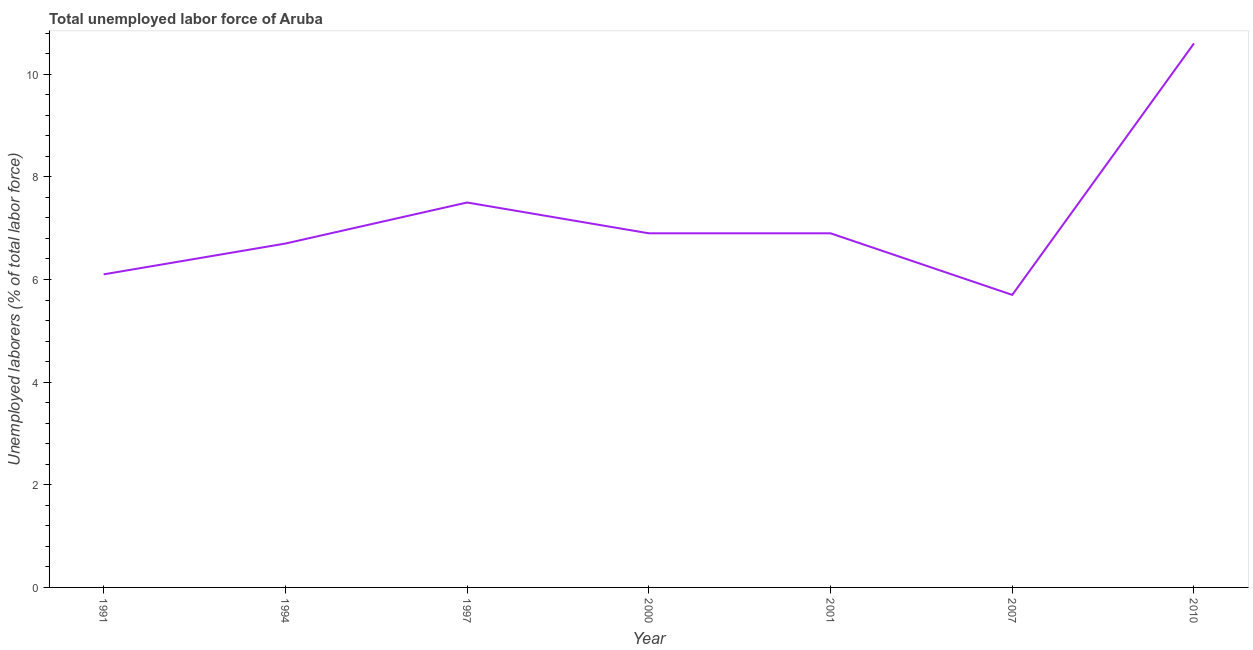What is the total unemployed labour force in 2001?
Provide a short and direct response. 6.9. Across all years, what is the maximum total unemployed labour force?
Provide a succinct answer. 10.6. Across all years, what is the minimum total unemployed labour force?
Make the answer very short. 5.7. What is the sum of the total unemployed labour force?
Make the answer very short. 50.4. What is the difference between the total unemployed labour force in 1994 and 2010?
Offer a very short reply. -3.9. What is the average total unemployed labour force per year?
Give a very brief answer. 7.2. What is the median total unemployed labour force?
Your answer should be very brief. 6.9. What is the ratio of the total unemployed labour force in 1997 to that in 2007?
Your answer should be very brief. 1.32. Is the total unemployed labour force in 2007 less than that in 2010?
Keep it short and to the point. Yes. Is the difference between the total unemployed labour force in 1991 and 2001 greater than the difference between any two years?
Offer a terse response. No. What is the difference between the highest and the second highest total unemployed labour force?
Your response must be concise. 3.1. What is the difference between the highest and the lowest total unemployed labour force?
Offer a very short reply. 4.9. How many lines are there?
Your answer should be compact. 1. What is the difference between two consecutive major ticks on the Y-axis?
Your answer should be compact. 2. Does the graph contain grids?
Keep it short and to the point. No. What is the title of the graph?
Offer a terse response. Total unemployed labor force of Aruba. What is the label or title of the Y-axis?
Offer a terse response. Unemployed laborers (% of total labor force). What is the Unemployed laborers (% of total labor force) in 1991?
Provide a short and direct response. 6.1. What is the Unemployed laborers (% of total labor force) of 1994?
Provide a succinct answer. 6.7. What is the Unemployed laborers (% of total labor force) of 1997?
Offer a terse response. 7.5. What is the Unemployed laborers (% of total labor force) of 2000?
Provide a short and direct response. 6.9. What is the Unemployed laborers (% of total labor force) of 2001?
Your answer should be compact. 6.9. What is the Unemployed laborers (% of total labor force) in 2007?
Your answer should be very brief. 5.7. What is the Unemployed laborers (% of total labor force) in 2010?
Your answer should be compact. 10.6. What is the difference between the Unemployed laborers (% of total labor force) in 1991 and 1994?
Make the answer very short. -0.6. What is the difference between the Unemployed laborers (% of total labor force) in 1991 and 1997?
Your answer should be compact. -1.4. What is the difference between the Unemployed laborers (% of total labor force) in 1991 and 2000?
Ensure brevity in your answer.  -0.8. What is the difference between the Unemployed laborers (% of total labor force) in 1991 and 2010?
Provide a succinct answer. -4.5. What is the difference between the Unemployed laborers (% of total labor force) in 1994 and 1997?
Your answer should be compact. -0.8. What is the difference between the Unemployed laborers (% of total labor force) in 1994 and 2001?
Ensure brevity in your answer.  -0.2. What is the difference between the Unemployed laborers (% of total labor force) in 1994 and 2007?
Make the answer very short. 1. What is the difference between the Unemployed laborers (% of total labor force) in 1994 and 2010?
Ensure brevity in your answer.  -3.9. What is the difference between the Unemployed laborers (% of total labor force) in 1997 and 2000?
Ensure brevity in your answer.  0.6. What is the difference between the Unemployed laborers (% of total labor force) in 1997 and 2007?
Make the answer very short. 1.8. What is the difference between the Unemployed laborers (% of total labor force) in 1997 and 2010?
Your answer should be very brief. -3.1. What is the difference between the Unemployed laborers (% of total labor force) in 2000 and 2001?
Give a very brief answer. 0. What is the difference between the Unemployed laborers (% of total labor force) in 2001 and 2007?
Give a very brief answer. 1.2. What is the difference between the Unemployed laborers (% of total labor force) in 2001 and 2010?
Offer a very short reply. -3.7. What is the difference between the Unemployed laborers (% of total labor force) in 2007 and 2010?
Offer a terse response. -4.9. What is the ratio of the Unemployed laborers (% of total labor force) in 1991 to that in 1994?
Give a very brief answer. 0.91. What is the ratio of the Unemployed laborers (% of total labor force) in 1991 to that in 1997?
Keep it short and to the point. 0.81. What is the ratio of the Unemployed laborers (% of total labor force) in 1991 to that in 2000?
Your answer should be very brief. 0.88. What is the ratio of the Unemployed laborers (% of total labor force) in 1991 to that in 2001?
Provide a short and direct response. 0.88. What is the ratio of the Unemployed laborers (% of total labor force) in 1991 to that in 2007?
Give a very brief answer. 1.07. What is the ratio of the Unemployed laborers (% of total labor force) in 1991 to that in 2010?
Your response must be concise. 0.57. What is the ratio of the Unemployed laborers (% of total labor force) in 1994 to that in 1997?
Give a very brief answer. 0.89. What is the ratio of the Unemployed laborers (% of total labor force) in 1994 to that in 2001?
Offer a terse response. 0.97. What is the ratio of the Unemployed laborers (% of total labor force) in 1994 to that in 2007?
Make the answer very short. 1.18. What is the ratio of the Unemployed laborers (% of total labor force) in 1994 to that in 2010?
Offer a terse response. 0.63. What is the ratio of the Unemployed laborers (% of total labor force) in 1997 to that in 2000?
Offer a very short reply. 1.09. What is the ratio of the Unemployed laborers (% of total labor force) in 1997 to that in 2001?
Ensure brevity in your answer.  1.09. What is the ratio of the Unemployed laborers (% of total labor force) in 1997 to that in 2007?
Keep it short and to the point. 1.32. What is the ratio of the Unemployed laborers (% of total labor force) in 1997 to that in 2010?
Offer a very short reply. 0.71. What is the ratio of the Unemployed laborers (% of total labor force) in 2000 to that in 2001?
Ensure brevity in your answer.  1. What is the ratio of the Unemployed laborers (% of total labor force) in 2000 to that in 2007?
Your answer should be compact. 1.21. What is the ratio of the Unemployed laborers (% of total labor force) in 2000 to that in 2010?
Your answer should be compact. 0.65. What is the ratio of the Unemployed laborers (% of total labor force) in 2001 to that in 2007?
Ensure brevity in your answer.  1.21. What is the ratio of the Unemployed laborers (% of total labor force) in 2001 to that in 2010?
Offer a terse response. 0.65. What is the ratio of the Unemployed laborers (% of total labor force) in 2007 to that in 2010?
Keep it short and to the point. 0.54. 